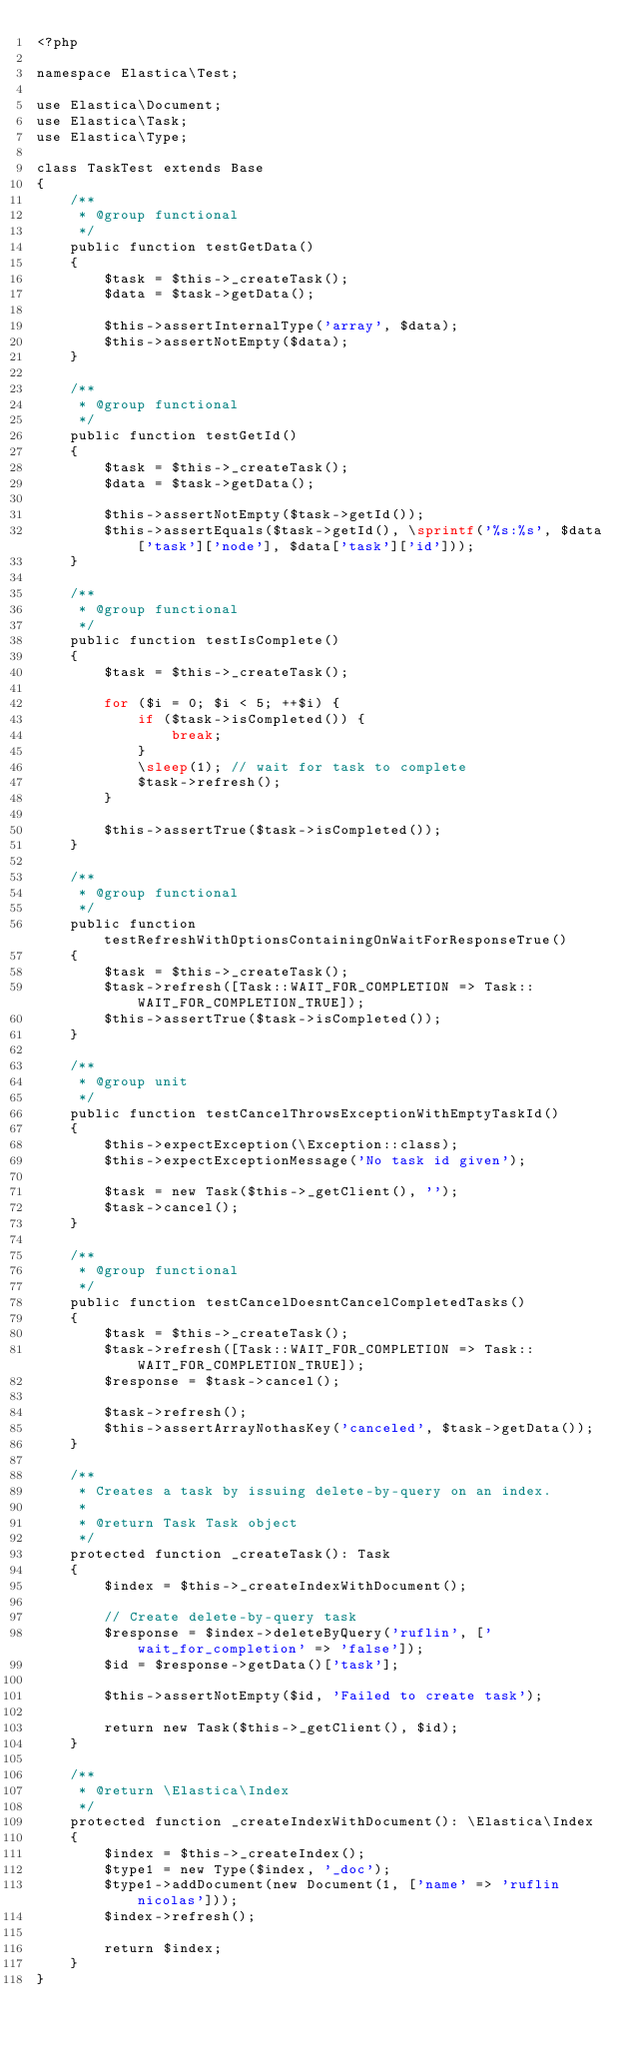<code> <loc_0><loc_0><loc_500><loc_500><_PHP_><?php

namespace Elastica\Test;

use Elastica\Document;
use Elastica\Task;
use Elastica\Type;

class TaskTest extends Base
{
    /**
     * @group functional
     */
    public function testGetData()
    {
        $task = $this->_createTask();
        $data = $task->getData();

        $this->assertInternalType('array', $data);
        $this->assertNotEmpty($data);
    }

    /**
     * @group functional
     */
    public function testGetId()
    {
        $task = $this->_createTask();
        $data = $task->getData();

        $this->assertNotEmpty($task->getId());
        $this->assertEquals($task->getId(), \sprintf('%s:%s', $data['task']['node'], $data['task']['id']));
    }

    /**
     * @group functional
     */
    public function testIsComplete()
    {
        $task = $this->_createTask();

        for ($i = 0; $i < 5; ++$i) {
            if ($task->isCompleted()) {
                break;
            }
            \sleep(1); // wait for task to complete
            $task->refresh();
        }

        $this->assertTrue($task->isCompleted());
    }

    /**
     * @group functional
     */
    public function testRefreshWithOptionsContainingOnWaitForResponseTrue()
    {
        $task = $this->_createTask();
        $task->refresh([Task::WAIT_FOR_COMPLETION => Task::WAIT_FOR_COMPLETION_TRUE]);
        $this->assertTrue($task->isCompleted());
    }

    /**
     * @group unit
     */
    public function testCancelThrowsExceptionWithEmptyTaskId()
    {
        $this->expectException(\Exception::class);
        $this->expectExceptionMessage('No task id given');

        $task = new Task($this->_getClient(), '');
        $task->cancel();
    }

    /**
     * @group functional
     */
    public function testCancelDoesntCancelCompletedTasks()
    {
        $task = $this->_createTask();
        $task->refresh([Task::WAIT_FOR_COMPLETION => Task::WAIT_FOR_COMPLETION_TRUE]);
        $response = $task->cancel();

        $task->refresh();
        $this->assertArrayNothasKey('canceled', $task->getData());
    }

    /**
     * Creates a task by issuing delete-by-query on an index.
     *
     * @return Task Task object
     */
    protected function _createTask(): Task
    {
        $index = $this->_createIndexWithDocument();

        // Create delete-by-query task
        $response = $index->deleteByQuery('ruflin', ['wait_for_completion' => 'false']);
        $id = $response->getData()['task'];

        $this->assertNotEmpty($id, 'Failed to create task');

        return new Task($this->_getClient(), $id);
    }

    /**
     * @return \Elastica\Index
     */
    protected function _createIndexWithDocument(): \Elastica\Index
    {
        $index = $this->_createIndex();
        $type1 = new Type($index, '_doc');
        $type1->addDocument(new Document(1, ['name' => 'ruflin nicolas']));
        $index->refresh();

        return $index;
    }
}
</code> 